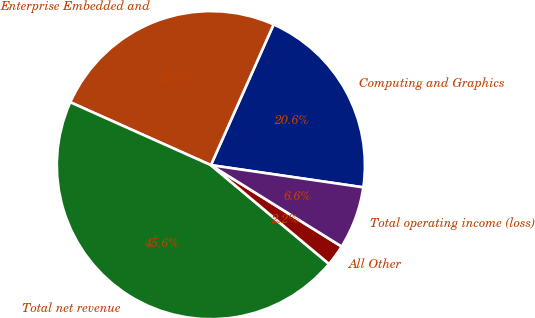Convert chart to OTSL. <chart><loc_0><loc_0><loc_500><loc_500><pie_chart><fcel>Computing and Graphics<fcel>Enterprise Embedded and<fcel>Total net revenue<fcel>All Other<fcel>Total operating income (loss)<nl><fcel>20.63%<fcel>24.98%<fcel>45.61%<fcel>2.22%<fcel>6.56%<nl></chart> 